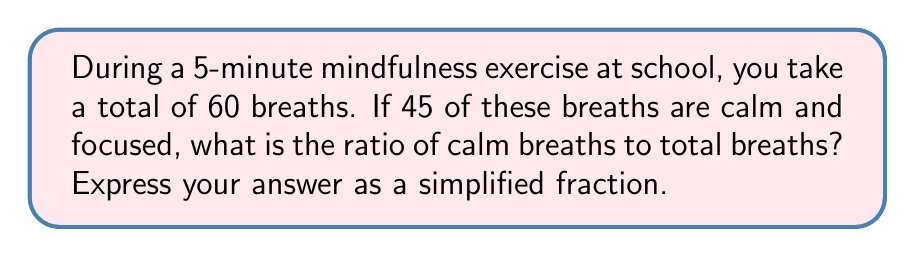Could you help me with this problem? Let's approach this step-by-step:

1. Identify the given information:
   * Total breaths: 60
   * Calm breaths: 45

2. Set up the ratio:
   * Ratio = Calm breaths : Total breaths
   * Ratio = 45 : 60

3. To simplify this ratio, we need to find the greatest common divisor (GCD) of 45 and 60:
   * Factors of 45: 1, 3, 5, 9, 15, 45
   * Factors of 60: 1, 2, 3, 4, 5, 6, 10, 12, 15, 20, 30, 60
   * The greatest common divisor is 15

4. Divide both terms of the ratio by the GCD:
   * $\frac{45}{15} : \frac{60}{15}$
   * $3 : 4$

Therefore, the simplified ratio of calm breaths to total breaths is 3:4.
Answer: $3:4$ 